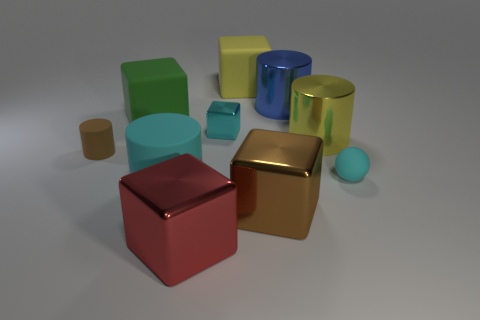There is another cylinder that is the same material as the small cylinder; what is its color?
Offer a very short reply. Cyan. Does the blue object have the same size as the cyan matte object left of the ball?
Provide a succinct answer. Yes. There is a cylinder that is to the left of the cyan matte thing that is on the left side of the rubber thing that is to the right of the large yellow matte thing; how big is it?
Offer a terse response. Small. How many metallic objects are blue objects or tiny blocks?
Keep it short and to the point. 2. There is a large metallic thing that is on the left side of the large yellow rubber object; what is its color?
Offer a very short reply. Red. There is a cyan thing that is the same size as the yellow metallic cylinder; what is its shape?
Give a very brief answer. Cylinder. There is a large rubber cylinder; does it have the same color as the small thing that is behind the big yellow metallic cylinder?
Offer a terse response. Yes. How many things are either big yellow objects that are on the right side of the blue metal cylinder or objects that are on the right side of the tiny shiny object?
Give a very brief answer. 5. What material is the sphere that is the same size as the brown rubber cylinder?
Your response must be concise. Rubber. How many other things are made of the same material as the blue cylinder?
Your answer should be very brief. 4. 